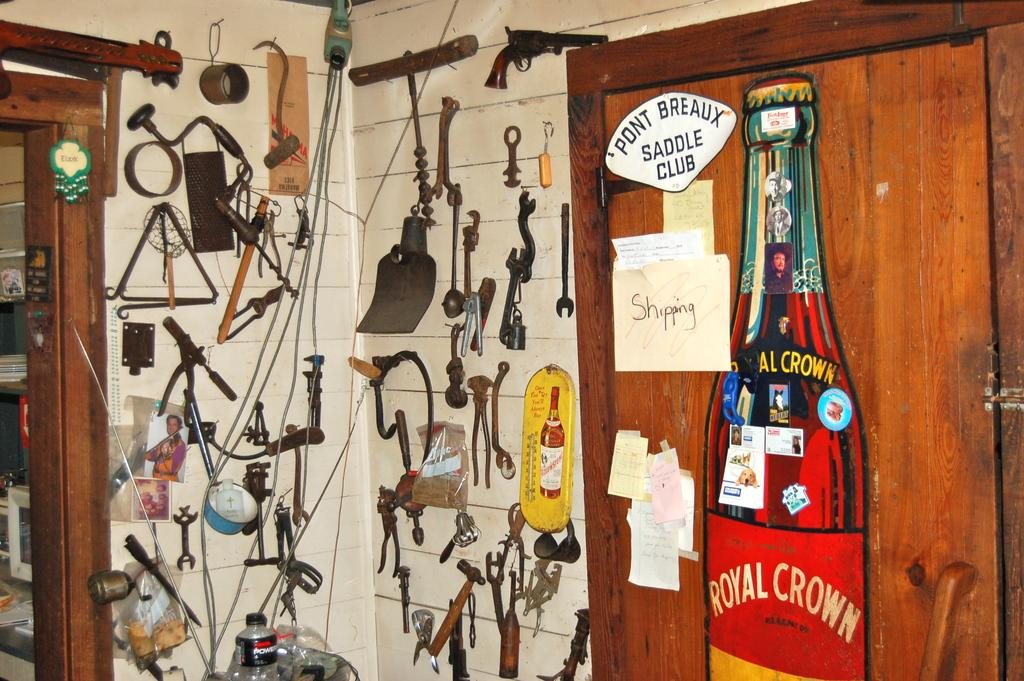What type of objects are hanging on the wall in the image? There are hardware tools on the wall in the image. Can you describe any other objects in the image? Yes, there is a bottle in the image. What type of locket is hanging from the bottle in the image? There is no locket present in the image; it only features hardware tools on the wall and a bottle. 